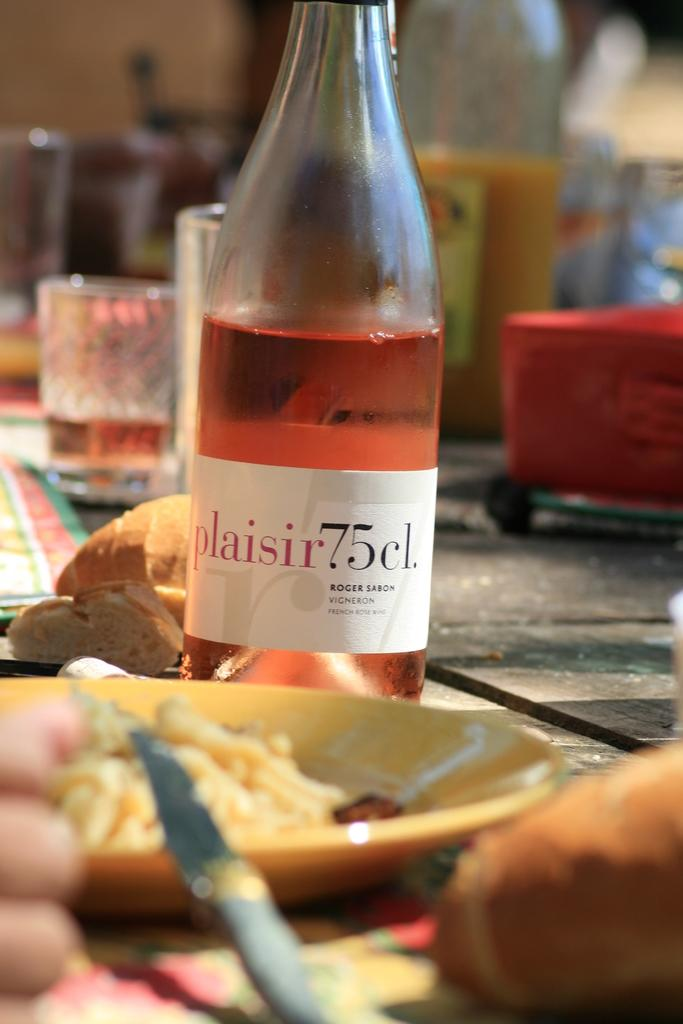What piece of furniture is present in the image? There is a table in the image. What is placed on the table? There is a juice bottle, a plate with salad, a knife, a glass of juice, and a box on the table. What type of food is on the plate? There is salad in the plate. What type of beverage is in the glass? There is juice in the glass. What type of wood is used to make the sea visible in the image? There is no sea present in the image, and therefore no wood is used to make it visible. 